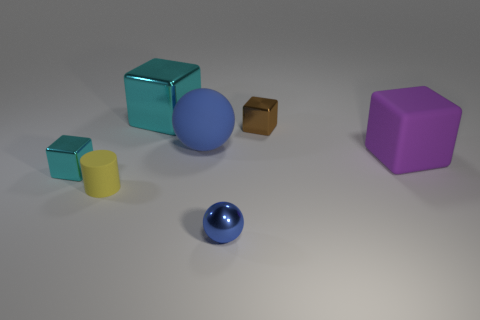Add 2 yellow objects. How many objects exist? 9 Subtract all spheres. How many objects are left? 5 Add 7 gray things. How many gray things exist? 7 Subtract 2 blue balls. How many objects are left? 5 Subtract all big matte cubes. Subtract all cyan metallic cylinders. How many objects are left? 6 Add 4 large purple rubber blocks. How many large purple rubber blocks are left? 5 